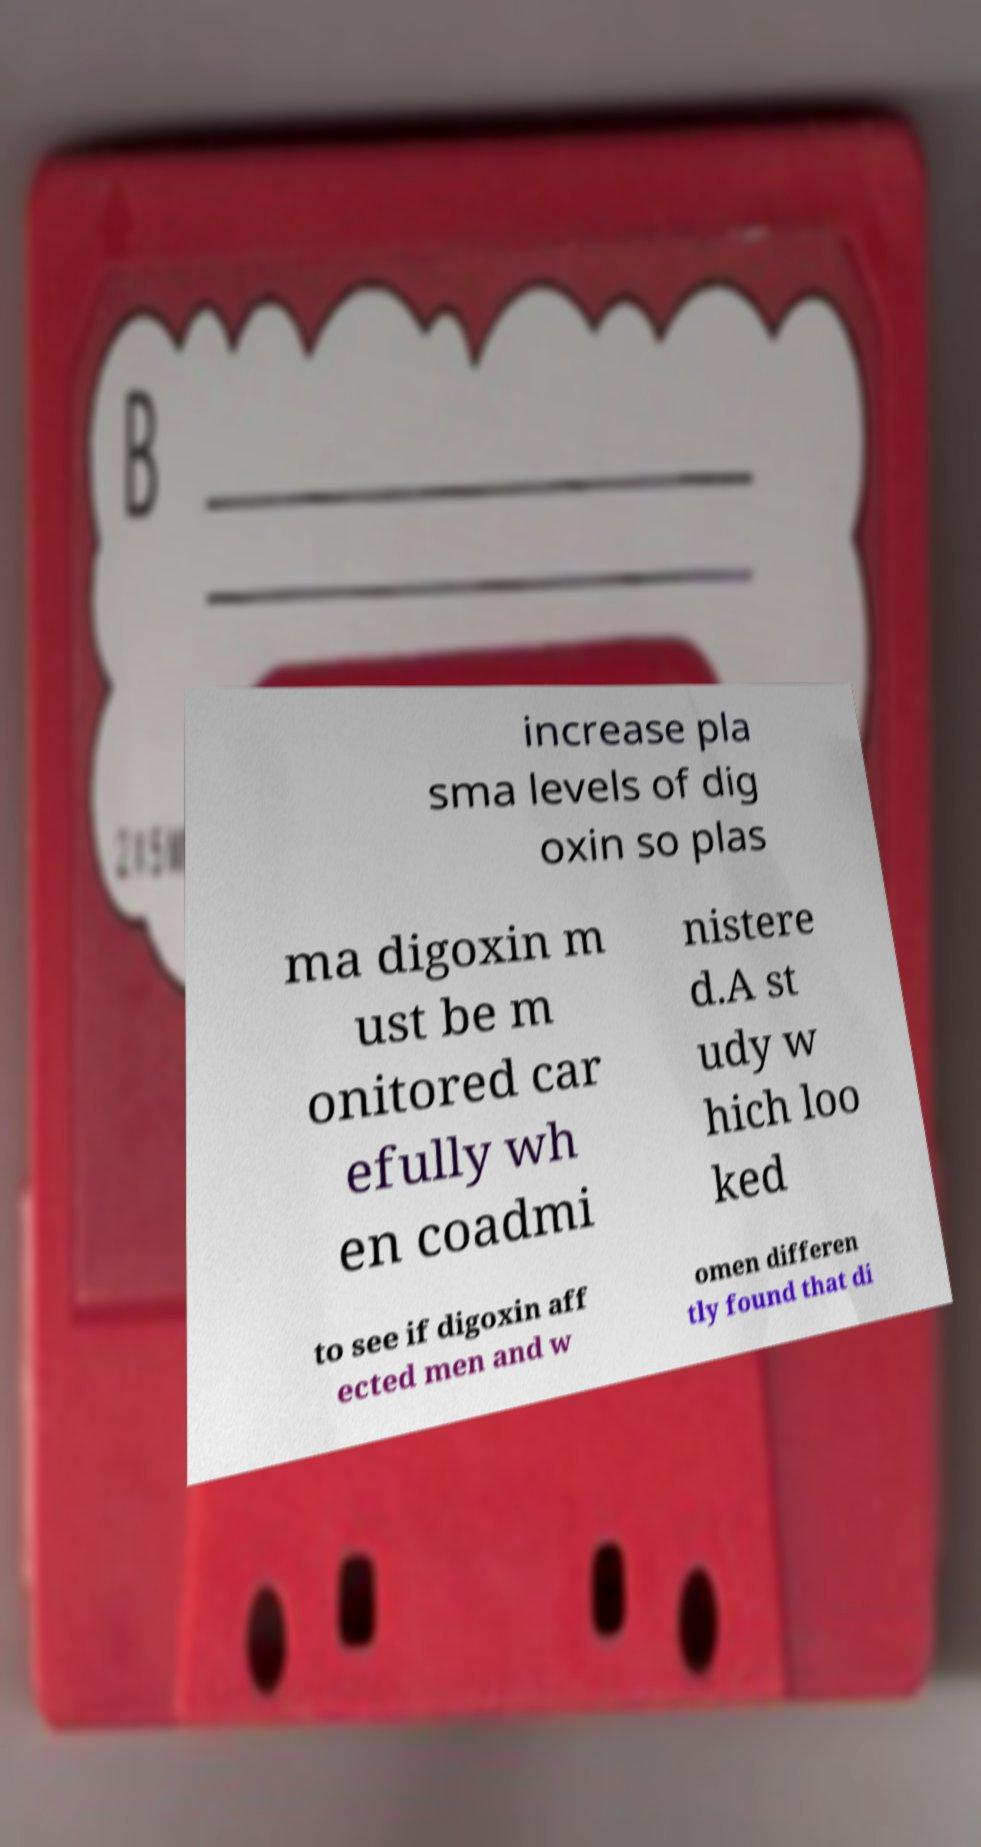Could you extract and type out the text from this image? increase pla sma levels of dig oxin so plas ma digoxin m ust be m onitored car efully wh en coadmi nistere d.A st udy w hich loo ked to see if digoxin aff ected men and w omen differen tly found that di 